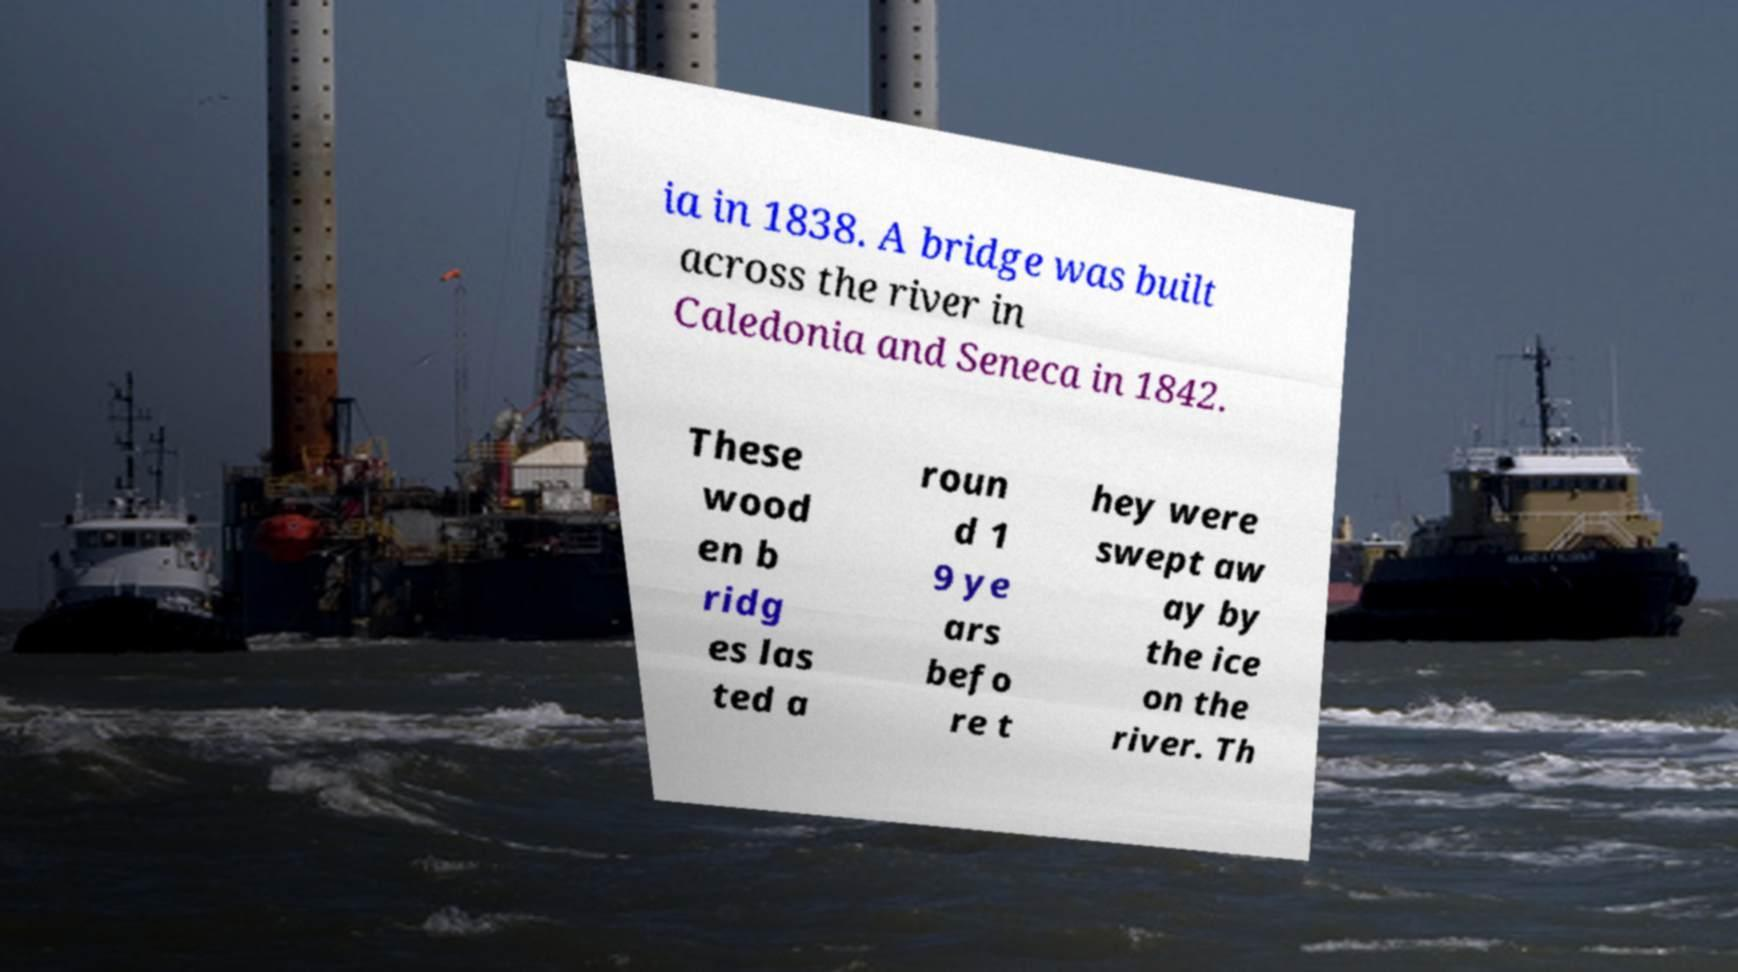Please read and relay the text visible in this image. What does it say? ia in 1838. A bridge was built across the river in Caledonia and Seneca in 1842. These wood en b ridg es las ted a roun d 1 9 ye ars befo re t hey were swept aw ay by the ice on the river. Th 